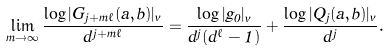Convert formula to latex. <formula><loc_0><loc_0><loc_500><loc_500>\lim _ { m \to \infty } \frac { \log | G _ { j + m \ell } ( a , b ) | _ { v } } { d ^ { j + m \ell } } = \frac { \log | g _ { 0 } | _ { v } } { d ^ { j } ( d ^ { \ell } - 1 ) } + \frac { \log | Q _ { j } ( a , b ) | _ { v } } { d ^ { j } } .</formula> 